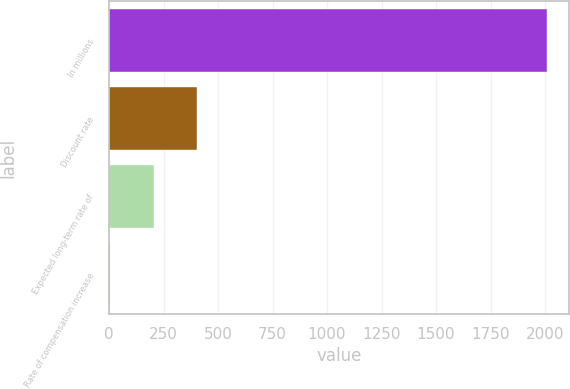<chart> <loc_0><loc_0><loc_500><loc_500><bar_chart><fcel>In millions<fcel>Discount rate<fcel>Expected long-term rate of<fcel>Rate of compensation increase<nl><fcel>2010<fcel>405.2<fcel>204.6<fcel>4<nl></chart> 